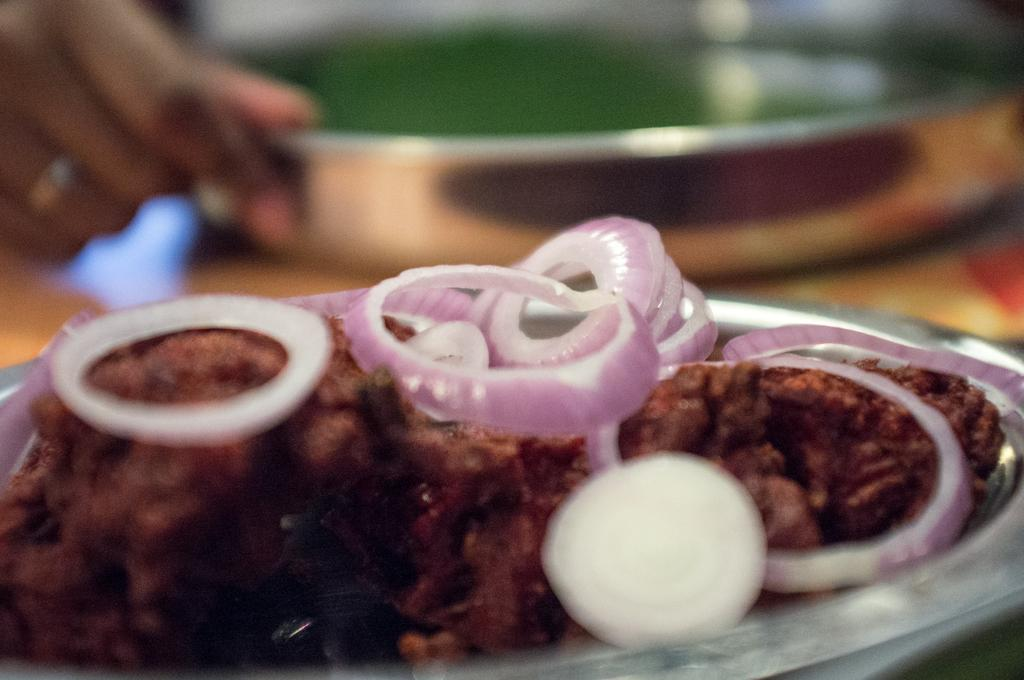What piece of furniture is present in the image? There is a table in the image. What is placed on the table? There are plates on the table, and there is food on the table. Can you describe any body parts visible in the image? A person's hand is visible in the image. What is the person's opinion about the hair in the image? There is no hair visible in the image, so it is not possible to determine the person's opinion about it. 